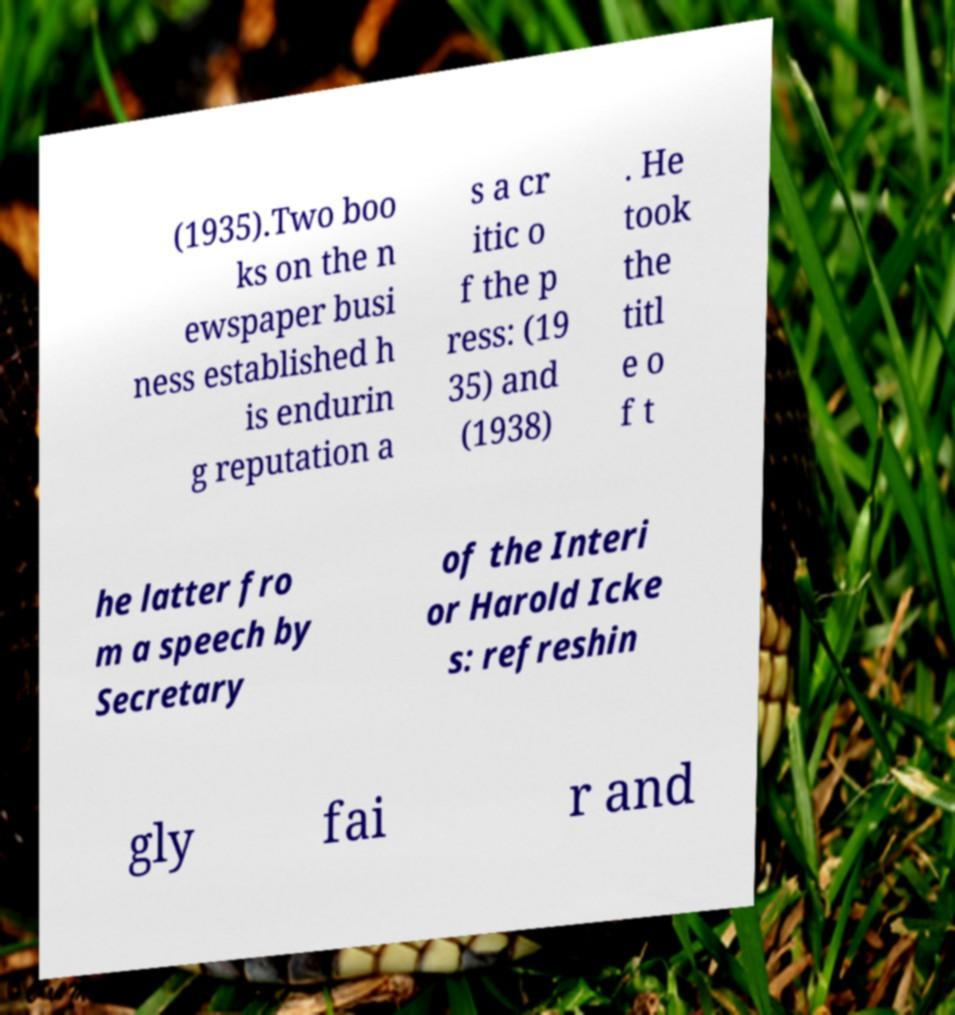Can you accurately transcribe the text from the provided image for me? (1935).Two boo ks on the n ewspaper busi ness established h is endurin g reputation a s a cr itic o f the p ress: (19 35) and (1938) . He took the titl e o f t he latter fro m a speech by Secretary of the Interi or Harold Icke s: refreshin gly fai r and 